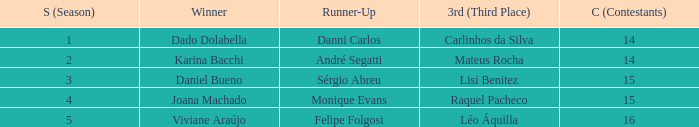In what season did Raquel Pacheco finish in third place? 4.0. 